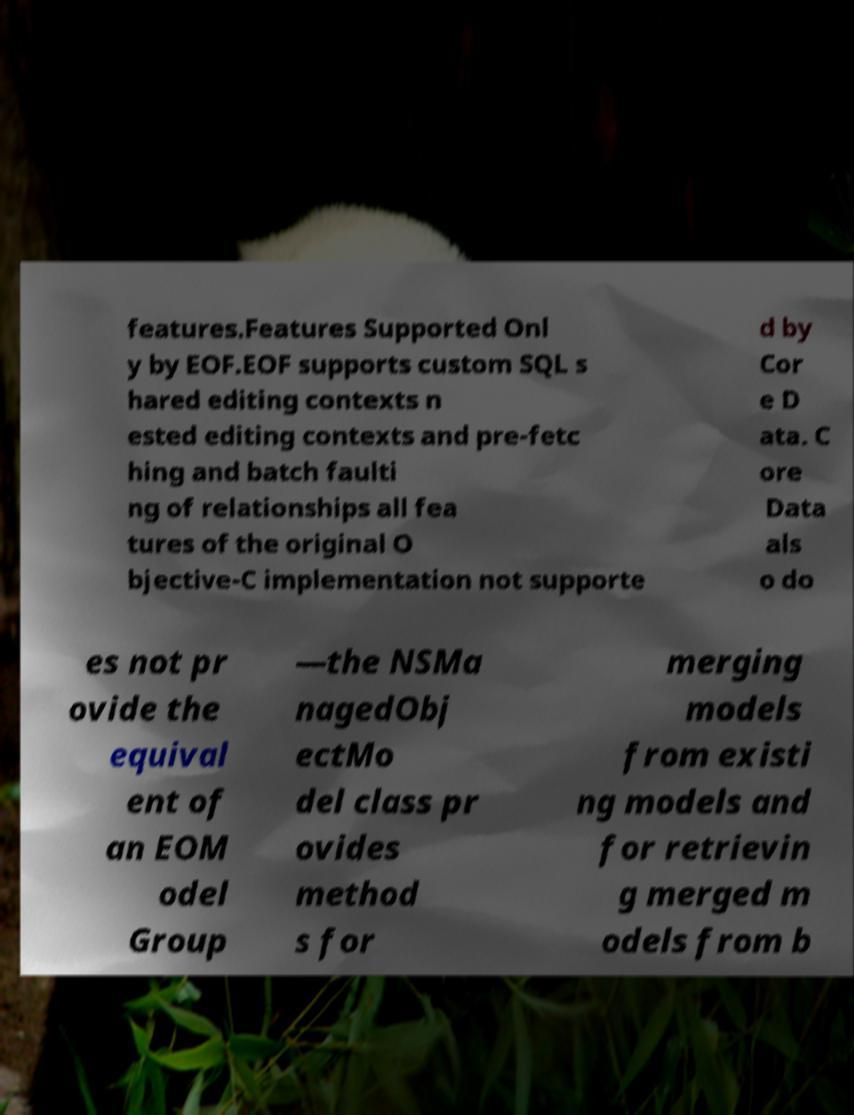There's text embedded in this image that I need extracted. Can you transcribe it verbatim? features.Features Supported Onl y by EOF.EOF supports custom SQL s hared editing contexts n ested editing contexts and pre-fetc hing and batch faulti ng of relationships all fea tures of the original O bjective-C implementation not supporte d by Cor e D ata. C ore Data als o do es not pr ovide the equival ent of an EOM odel Group —the NSMa nagedObj ectMo del class pr ovides method s for merging models from existi ng models and for retrievin g merged m odels from b 